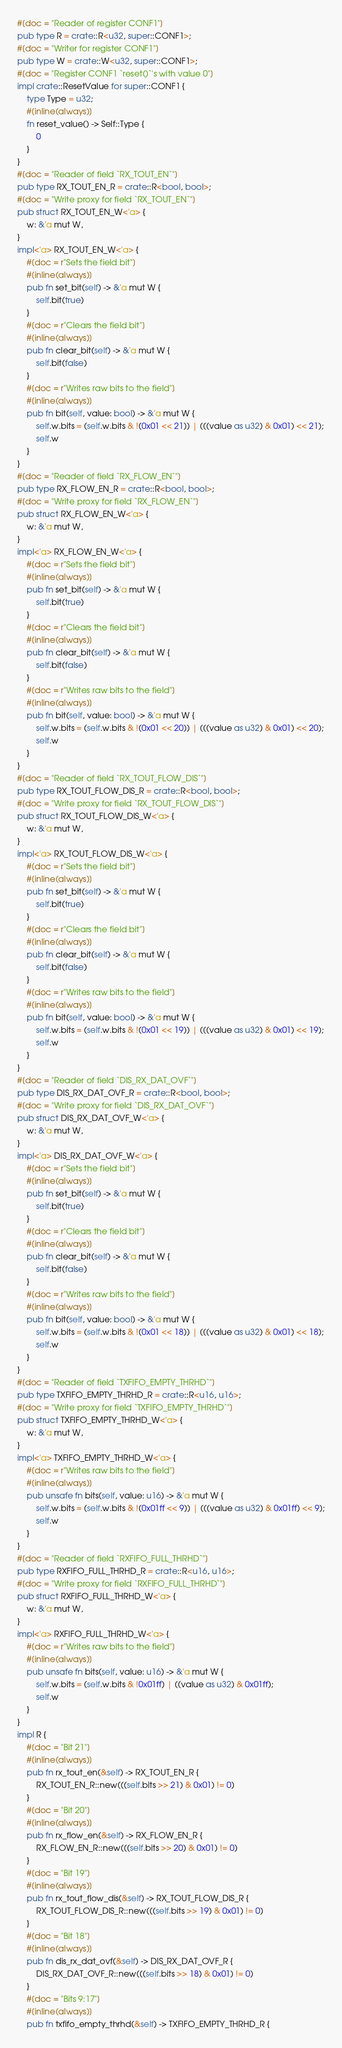<code> <loc_0><loc_0><loc_500><loc_500><_Rust_>#[doc = "Reader of register CONF1"]
pub type R = crate::R<u32, super::CONF1>;
#[doc = "Writer for register CONF1"]
pub type W = crate::W<u32, super::CONF1>;
#[doc = "Register CONF1 `reset()`'s with value 0"]
impl crate::ResetValue for super::CONF1 {
    type Type = u32;
    #[inline(always)]
    fn reset_value() -> Self::Type {
        0
    }
}
#[doc = "Reader of field `RX_TOUT_EN`"]
pub type RX_TOUT_EN_R = crate::R<bool, bool>;
#[doc = "Write proxy for field `RX_TOUT_EN`"]
pub struct RX_TOUT_EN_W<'a> {
    w: &'a mut W,
}
impl<'a> RX_TOUT_EN_W<'a> {
    #[doc = r"Sets the field bit"]
    #[inline(always)]
    pub fn set_bit(self) -> &'a mut W {
        self.bit(true)
    }
    #[doc = r"Clears the field bit"]
    #[inline(always)]
    pub fn clear_bit(self) -> &'a mut W {
        self.bit(false)
    }
    #[doc = r"Writes raw bits to the field"]
    #[inline(always)]
    pub fn bit(self, value: bool) -> &'a mut W {
        self.w.bits = (self.w.bits & !(0x01 << 21)) | (((value as u32) & 0x01) << 21);
        self.w
    }
}
#[doc = "Reader of field `RX_FLOW_EN`"]
pub type RX_FLOW_EN_R = crate::R<bool, bool>;
#[doc = "Write proxy for field `RX_FLOW_EN`"]
pub struct RX_FLOW_EN_W<'a> {
    w: &'a mut W,
}
impl<'a> RX_FLOW_EN_W<'a> {
    #[doc = r"Sets the field bit"]
    #[inline(always)]
    pub fn set_bit(self) -> &'a mut W {
        self.bit(true)
    }
    #[doc = r"Clears the field bit"]
    #[inline(always)]
    pub fn clear_bit(self) -> &'a mut W {
        self.bit(false)
    }
    #[doc = r"Writes raw bits to the field"]
    #[inline(always)]
    pub fn bit(self, value: bool) -> &'a mut W {
        self.w.bits = (self.w.bits & !(0x01 << 20)) | (((value as u32) & 0x01) << 20);
        self.w
    }
}
#[doc = "Reader of field `RX_TOUT_FLOW_DIS`"]
pub type RX_TOUT_FLOW_DIS_R = crate::R<bool, bool>;
#[doc = "Write proxy for field `RX_TOUT_FLOW_DIS`"]
pub struct RX_TOUT_FLOW_DIS_W<'a> {
    w: &'a mut W,
}
impl<'a> RX_TOUT_FLOW_DIS_W<'a> {
    #[doc = r"Sets the field bit"]
    #[inline(always)]
    pub fn set_bit(self) -> &'a mut W {
        self.bit(true)
    }
    #[doc = r"Clears the field bit"]
    #[inline(always)]
    pub fn clear_bit(self) -> &'a mut W {
        self.bit(false)
    }
    #[doc = r"Writes raw bits to the field"]
    #[inline(always)]
    pub fn bit(self, value: bool) -> &'a mut W {
        self.w.bits = (self.w.bits & !(0x01 << 19)) | (((value as u32) & 0x01) << 19);
        self.w
    }
}
#[doc = "Reader of field `DIS_RX_DAT_OVF`"]
pub type DIS_RX_DAT_OVF_R = crate::R<bool, bool>;
#[doc = "Write proxy for field `DIS_RX_DAT_OVF`"]
pub struct DIS_RX_DAT_OVF_W<'a> {
    w: &'a mut W,
}
impl<'a> DIS_RX_DAT_OVF_W<'a> {
    #[doc = r"Sets the field bit"]
    #[inline(always)]
    pub fn set_bit(self) -> &'a mut W {
        self.bit(true)
    }
    #[doc = r"Clears the field bit"]
    #[inline(always)]
    pub fn clear_bit(self) -> &'a mut W {
        self.bit(false)
    }
    #[doc = r"Writes raw bits to the field"]
    #[inline(always)]
    pub fn bit(self, value: bool) -> &'a mut W {
        self.w.bits = (self.w.bits & !(0x01 << 18)) | (((value as u32) & 0x01) << 18);
        self.w
    }
}
#[doc = "Reader of field `TXFIFO_EMPTY_THRHD`"]
pub type TXFIFO_EMPTY_THRHD_R = crate::R<u16, u16>;
#[doc = "Write proxy for field `TXFIFO_EMPTY_THRHD`"]
pub struct TXFIFO_EMPTY_THRHD_W<'a> {
    w: &'a mut W,
}
impl<'a> TXFIFO_EMPTY_THRHD_W<'a> {
    #[doc = r"Writes raw bits to the field"]
    #[inline(always)]
    pub unsafe fn bits(self, value: u16) -> &'a mut W {
        self.w.bits = (self.w.bits & !(0x01ff << 9)) | (((value as u32) & 0x01ff) << 9);
        self.w
    }
}
#[doc = "Reader of field `RXFIFO_FULL_THRHD`"]
pub type RXFIFO_FULL_THRHD_R = crate::R<u16, u16>;
#[doc = "Write proxy for field `RXFIFO_FULL_THRHD`"]
pub struct RXFIFO_FULL_THRHD_W<'a> {
    w: &'a mut W,
}
impl<'a> RXFIFO_FULL_THRHD_W<'a> {
    #[doc = r"Writes raw bits to the field"]
    #[inline(always)]
    pub unsafe fn bits(self, value: u16) -> &'a mut W {
        self.w.bits = (self.w.bits & !0x01ff) | ((value as u32) & 0x01ff);
        self.w
    }
}
impl R {
    #[doc = "Bit 21"]
    #[inline(always)]
    pub fn rx_tout_en(&self) -> RX_TOUT_EN_R {
        RX_TOUT_EN_R::new(((self.bits >> 21) & 0x01) != 0)
    }
    #[doc = "Bit 20"]
    #[inline(always)]
    pub fn rx_flow_en(&self) -> RX_FLOW_EN_R {
        RX_FLOW_EN_R::new(((self.bits >> 20) & 0x01) != 0)
    }
    #[doc = "Bit 19"]
    #[inline(always)]
    pub fn rx_tout_flow_dis(&self) -> RX_TOUT_FLOW_DIS_R {
        RX_TOUT_FLOW_DIS_R::new(((self.bits >> 19) & 0x01) != 0)
    }
    #[doc = "Bit 18"]
    #[inline(always)]
    pub fn dis_rx_dat_ovf(&self) -> DIS_RX_DAT_OVF_R {
        DIS_RX_DAT_OVF_R::new(((self.bits >> 18) & 0x01) != 0)
    }
    #[doc = "Bits 9:17"]
    #[inline(always)]
    pub fn txfifo_empty_thrhd(&self) -> TXFIFO_EMPTY_THRHD_R {</code> 